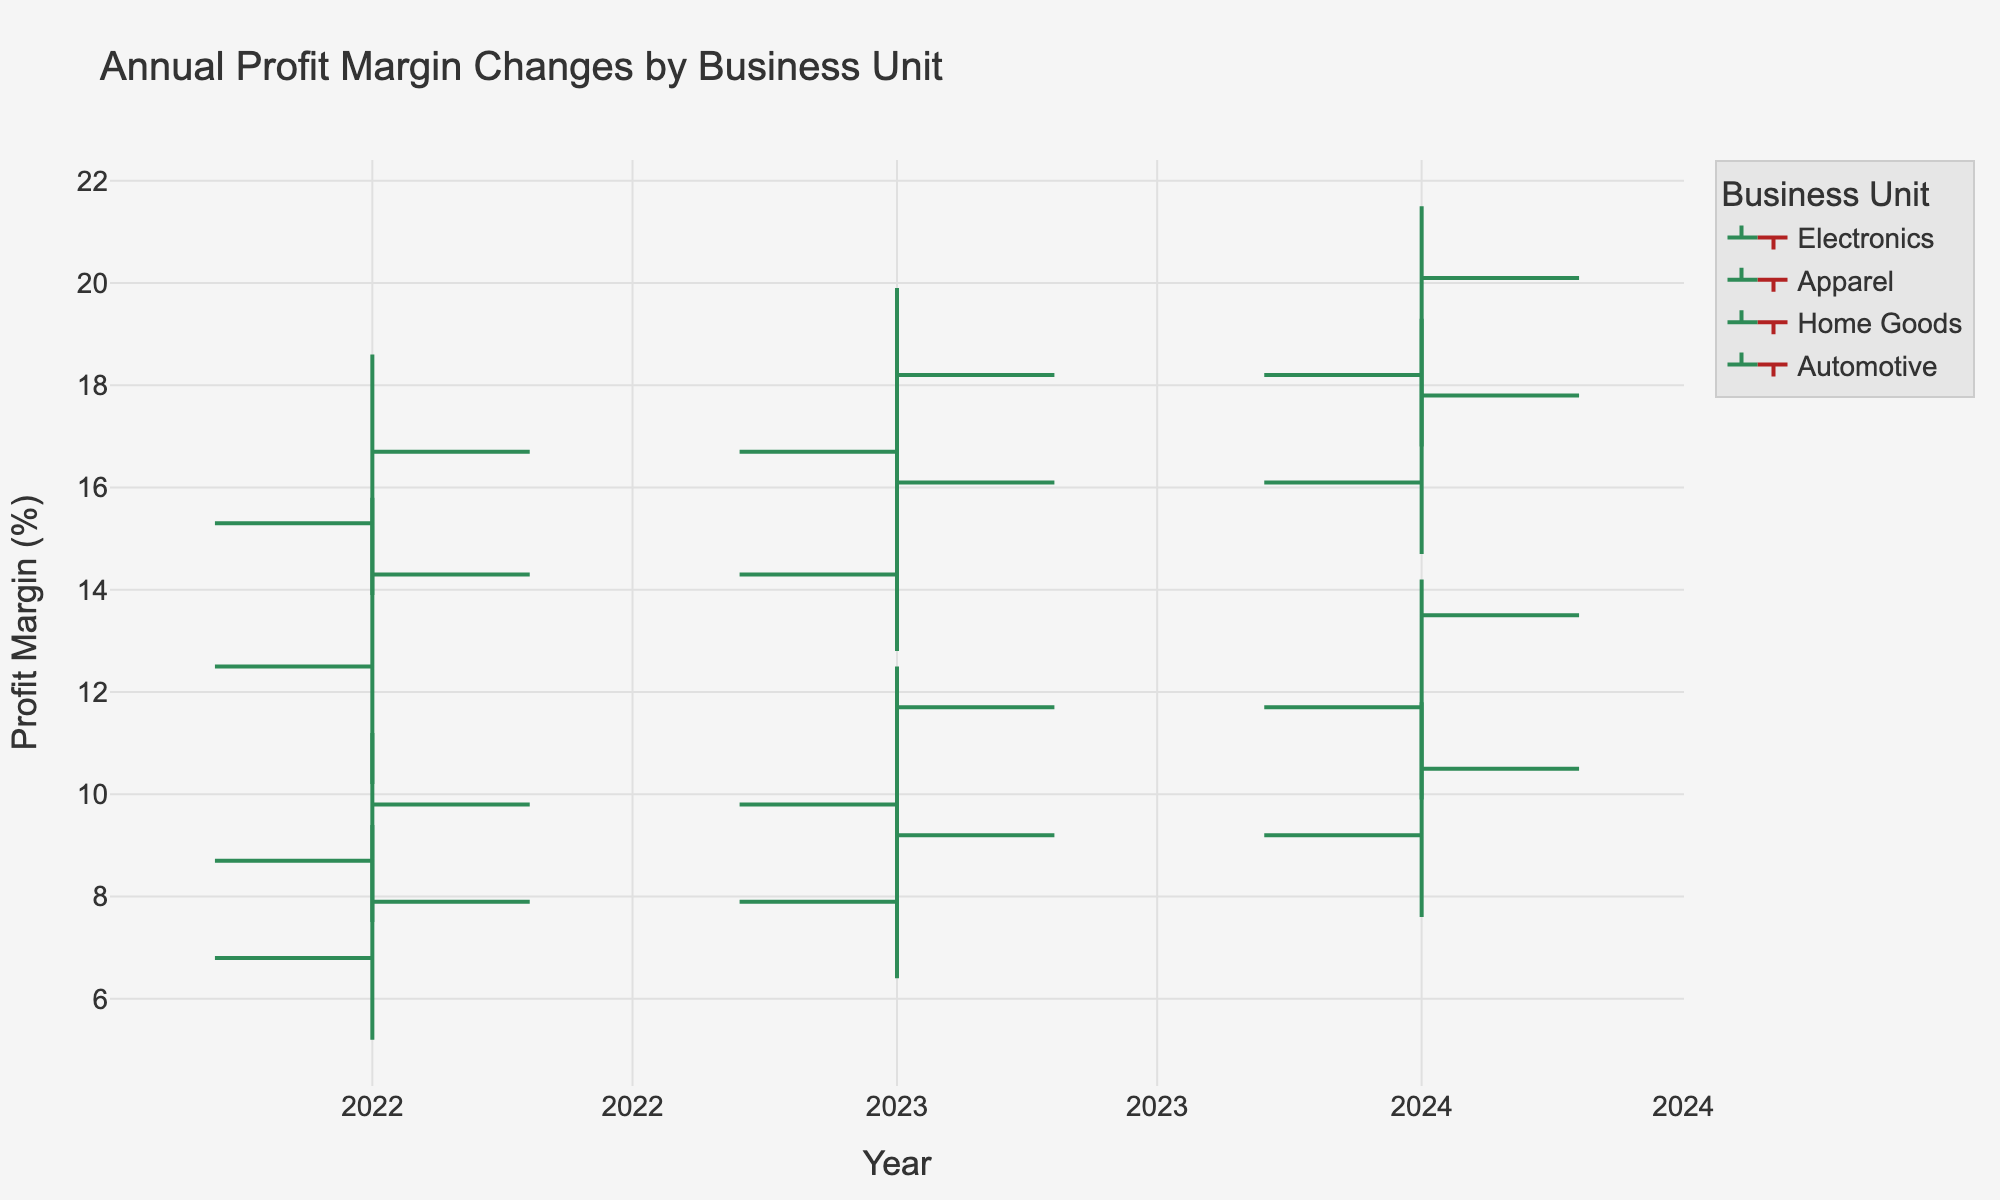What is the title of the chart? The title is typically found at the top of the chart, clearly labeled as such. This chart's title is “Annual Profit Margin Changes by Business Unit”
Answer: Annual Profit Margin Changes by Business Unit Which business unit has the highest closing profit margin in 2024? The "Close" values in the OHLC chart represent the closing profit margins. For the year 2024, Home Goods has the highest closing profit margin with a value of 20.1%.
Answer: Home Goods How did the profit margin for Electronics change from 2022 to 2023? To determine the change, we compare the closing profit margins of Electronics for 2022 and 2023. In 2022, it closed at 14.3%, and in 2023, it closed at 16.1%. The change is 16.1% - 14.3% = 1.8%.
Answer: Increased by 1.8% Which business unit experienced the smallest range in profit margins in 2023? The range of profit margins for each unit in 2023 can be found by subtracting the "Low" value from the "High" value. Calculations are: Electronics: 17.6 - 12.8 = 4.8, Apparel: 12.5 - 8.3 = 4.2, Home Goods: 19.9 - 14.5 = 5.4, Automotive: 10.6 - 6.4 = 4.2. Both Apparel and Automotive experienced the smallest range of 4.2.
Answer: Apparel and Automotive Which year had the highest overall high-profit margin for all business units combined? To determine this, we need to look at the "High" values for each year and identify the highest one. In 2022, the highest was 18.6% (Home Goods), in 2023, it was 19.9% (Home Goods), and in 2024, it was 21.5% (Home Goods). Therefore, 2024 had the highest overall high-profit margin.
Answer: 2024 What was the profit margin trend for Automotive from 2022 to 2024? Analyze the closing profit margins for Automotive over the years: 2022: 7.9%, 2023: 9.2%, 2024: 10.5%. Observe that the profit margin has consistently increased each year.
Answer: Increasing trend For Apparel, which year had the largest increase in profit margin compared to the previous year? We look at the closing margins for Apparel from one year to the next: From 2022 to 2023, the increase was 11.7% - 9.8% = 1.9%. From 2023 to 2024, the increase was 13.5% - 11.7% = 1.8%. The largest increase was from 2022 to 2023.
Answer: 2022 to 2023 In 2023, which business unit's closing profit margin was closest to its opening profit margin? To find this, compare the opening and closing values for each unit in 2023: Electronics: 16.1 - 14.3 = 1.8, Apparel: 11.7 - 9.8 = 1.9, Home Goods: 18.2 - 16.7 = 1.5, Automotive: 9.2 - 7.9 = 1.3. Automotive has the smallest difference of 1.3, so its closing profit margin was closest to its opening profit margin.
Answer: Automotive Which business unit showed the greatest volatility in 2024? Volatility can be assessed by the difference between the high and low values. In 2024, the differences are: Electronics: 19.3 - 14.7 = 4.6, Apparel: 14.2 - 9.9 = 4.3, Home Goods: 21.5 - 16.8 = 4.7, Automotive: 11.8 - 7.6 = 4.2. Home Goods has the greatest volatility with a range of 4.7.
Answer: Home Goods 